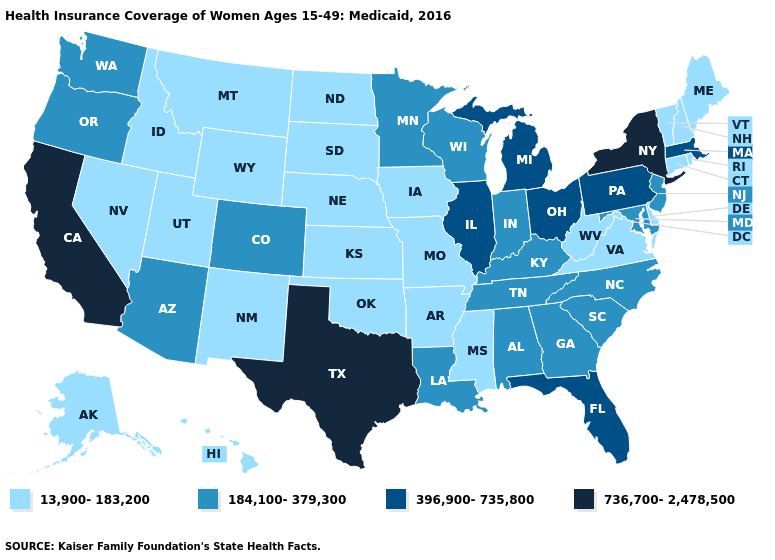What is the highest value in the South ?
Give a very brief answer. 736,700-2,478,500. What is the highest value in states that border Vermont?
Answer briefly. 736,700-2,478,500. Does the map have missing data?
Keep it brief. No. Among the states that border Delaware , which have the lowest value?
Keep it brief. Maryland, New Jersey. What is the value of Oklahoma?
Answer briefly. 13,900-183,200. What is the highest value in the West ?
Be succinct. 736,700-2,478,500. What is the value of California?
Concise answer only. 736,700-2,478,500. Does Idaho have a lower value than Pennsylvania?
Answer briefly. Yes. Among the states that border Arizona , which have the highest value?
Short answer required. California. Does the first symbol in the legend represent the smallest category?
Write a very short answer. Yes. Among the states that border Arkansas , does Mississippi have the lowest value?
Quick response, please. Yes. What is the lowest value in states that border Michigan?
Write a very short answer. 184,100-379,300. What is the value of Kentucky?
Short answer required. 184,100-379,300. Does Maryland have the lowest value in the USA?
Give a very brief answer. No. 